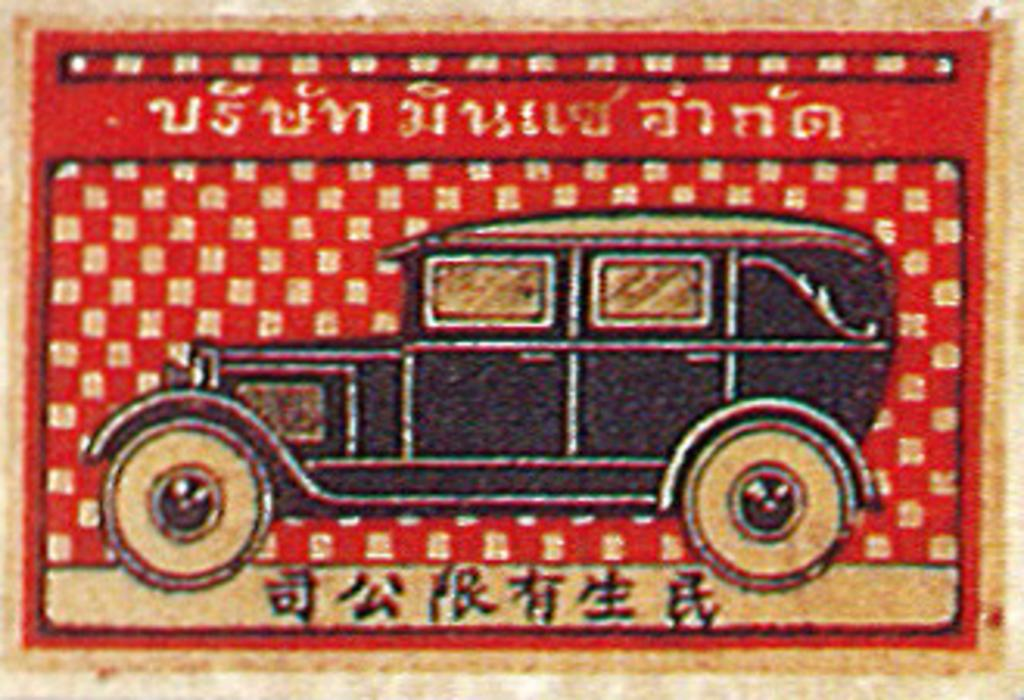What is the main subject of the poster in the image? The main subject of the poster in the image is a vehicle. What colors are used in the background of the poster? The background of the poster is red and gold. How many bells are hanging from the vehicle in the image? There are no bells present in the image; it features a poster of a vehicle with a red and gold background. What type of stocking is shown on the vehicle in the image? There is no stocking present on the vehicle in the image; it only features a vehicle and a red and gold background. 